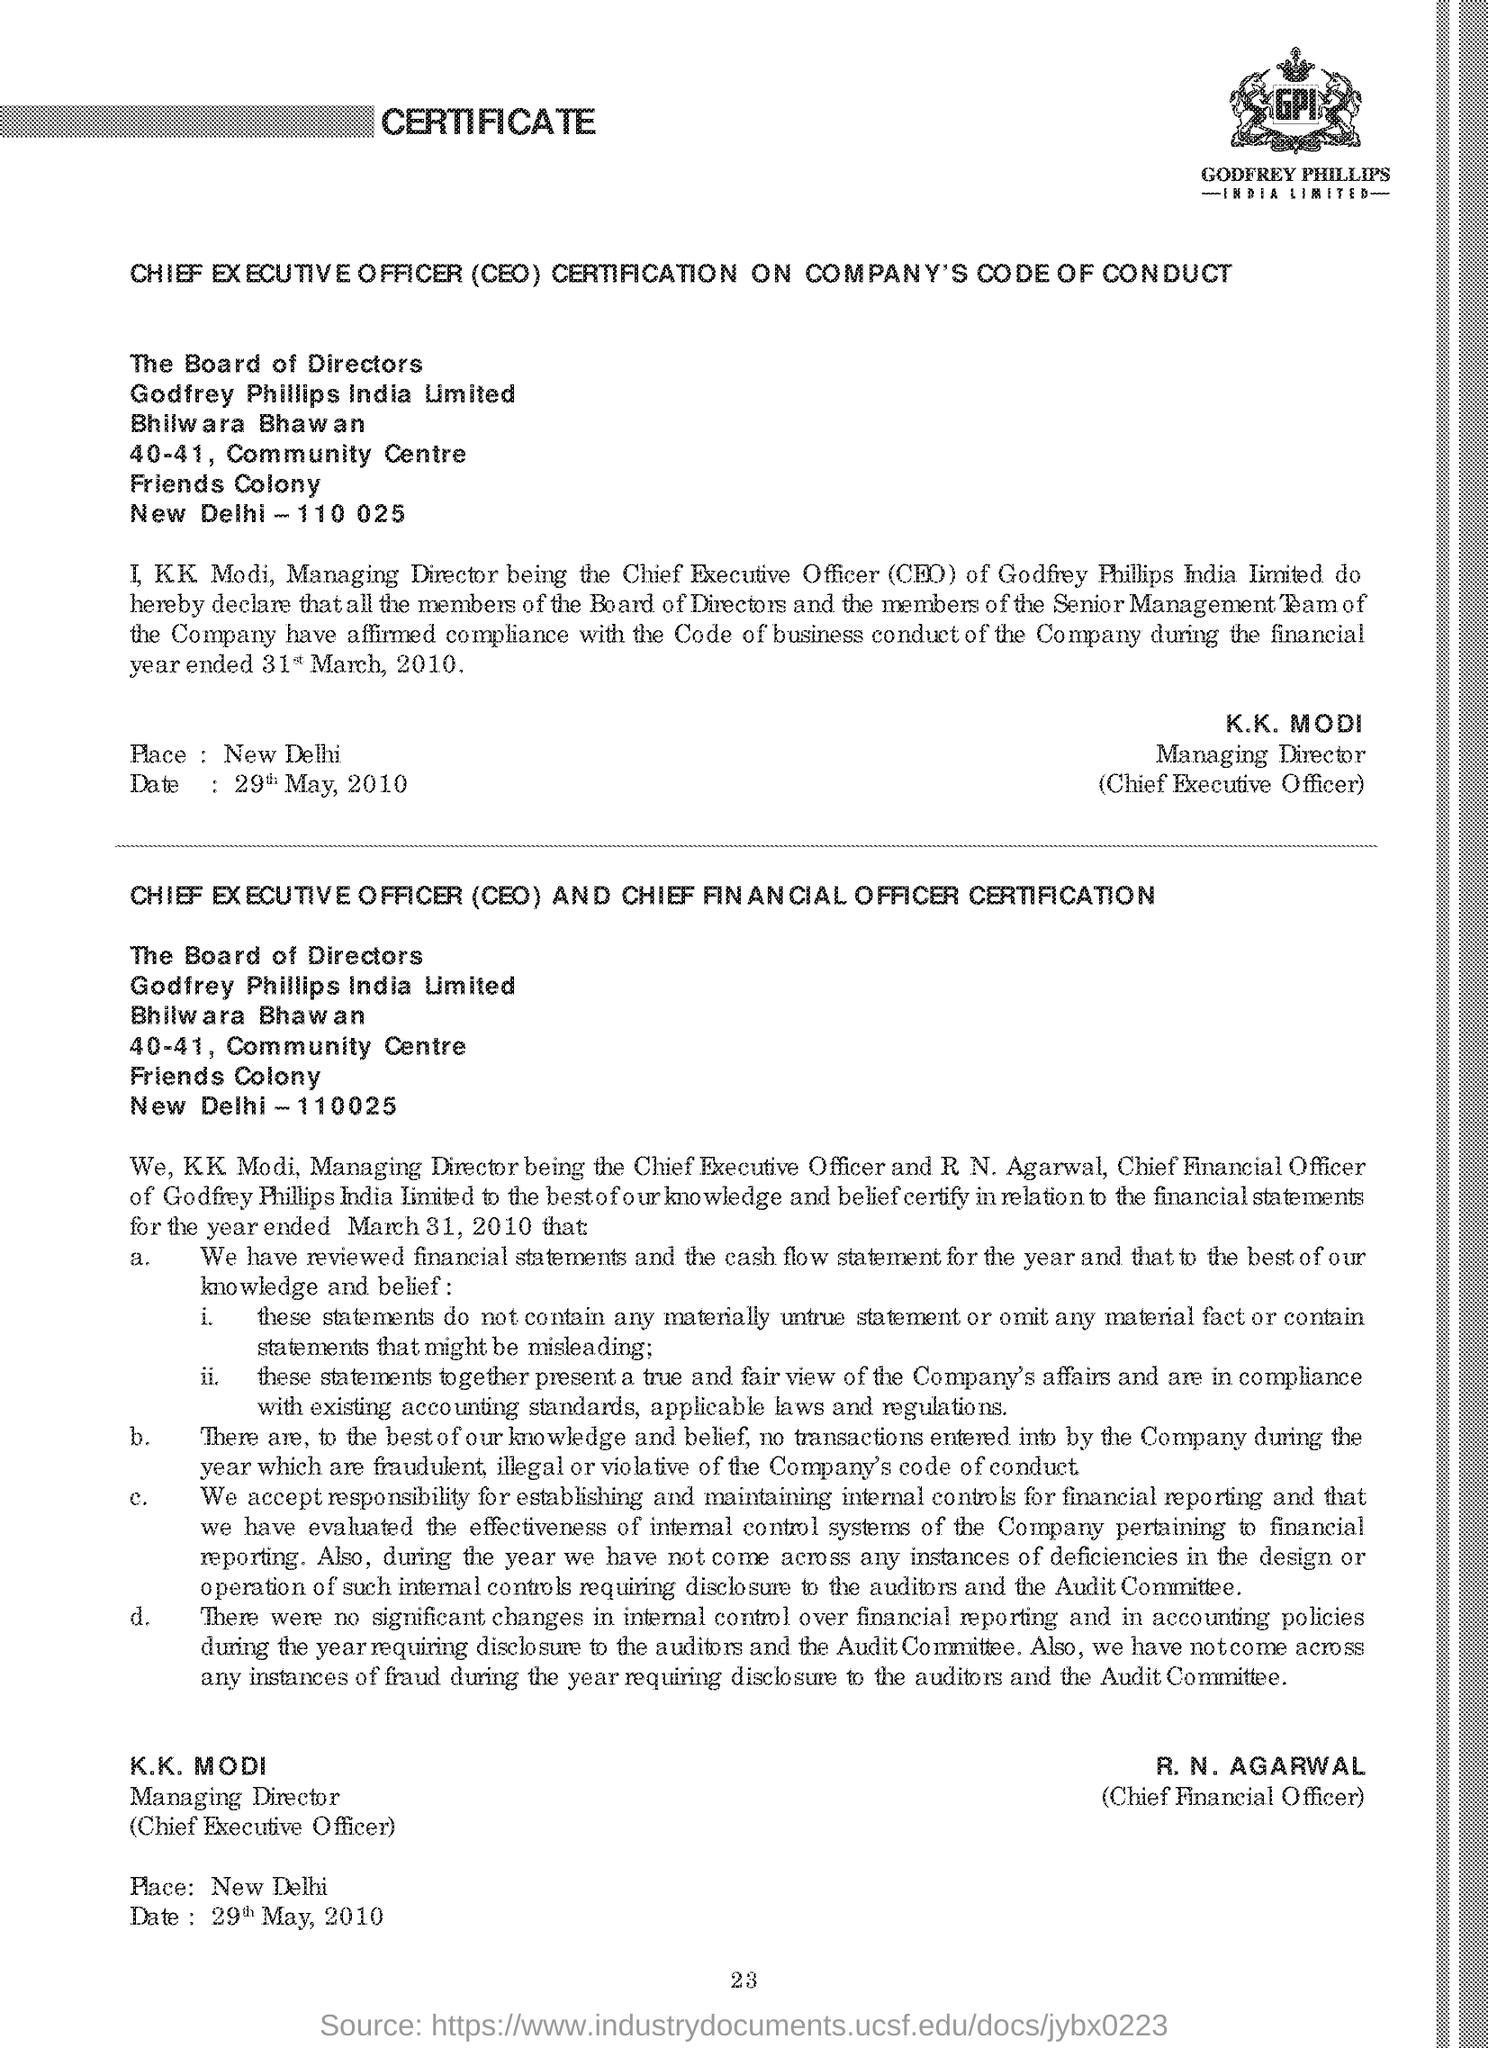Indicate a few pertinent items in this graphic. CEO stands for Chief Executive Officer, who is responsible for leading and managing a company's operations and strategic decision-making. The managing director of the company is KK Modi. The name of the Chief Financial Officer is R. N. AGARWAL. 